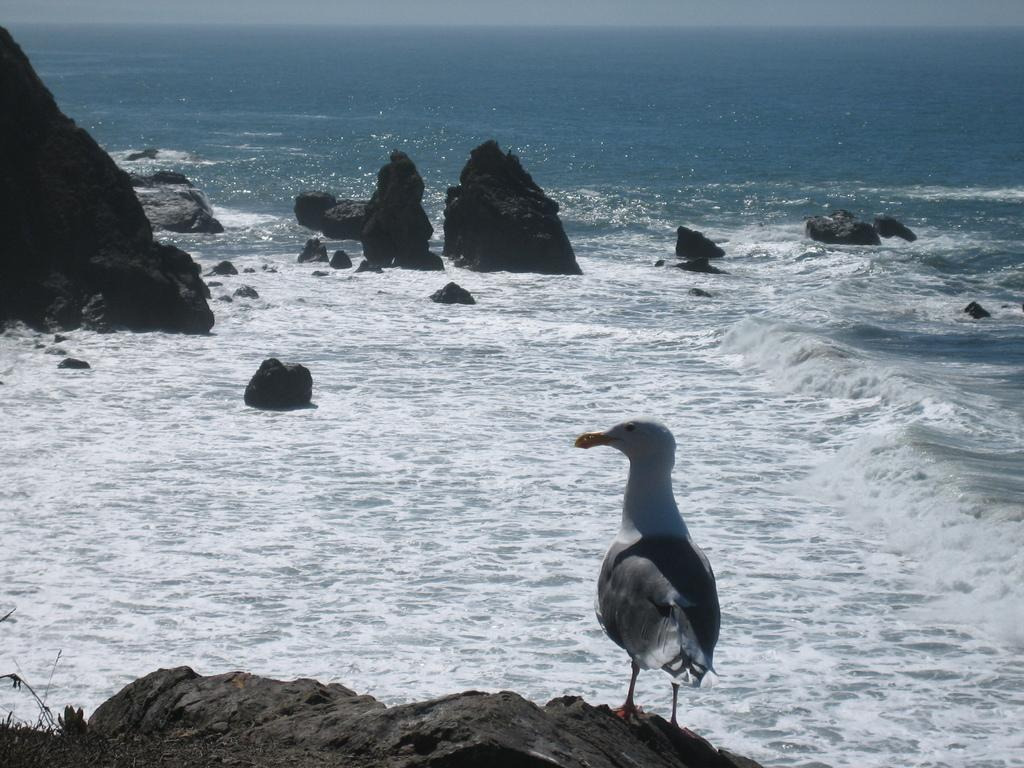What type of animal can be seen in the image? There is a bird in the image. Where is the bird located? The bird is standing on a rock. What can be seen in the background of the image? There is water and rocks visible in the background of the image. What type of yarn is the bird using to knit a sweater in the image? There is no yarn or sweater present in the image; it features a bird standing on a rock with water and rocks visible in the background. 